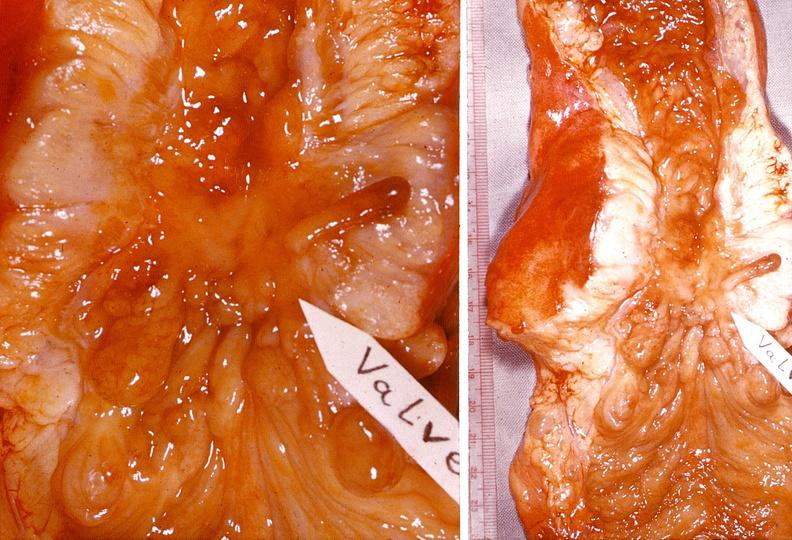what does this image show?
Answer the question using a single word or phrase. Small intestine 